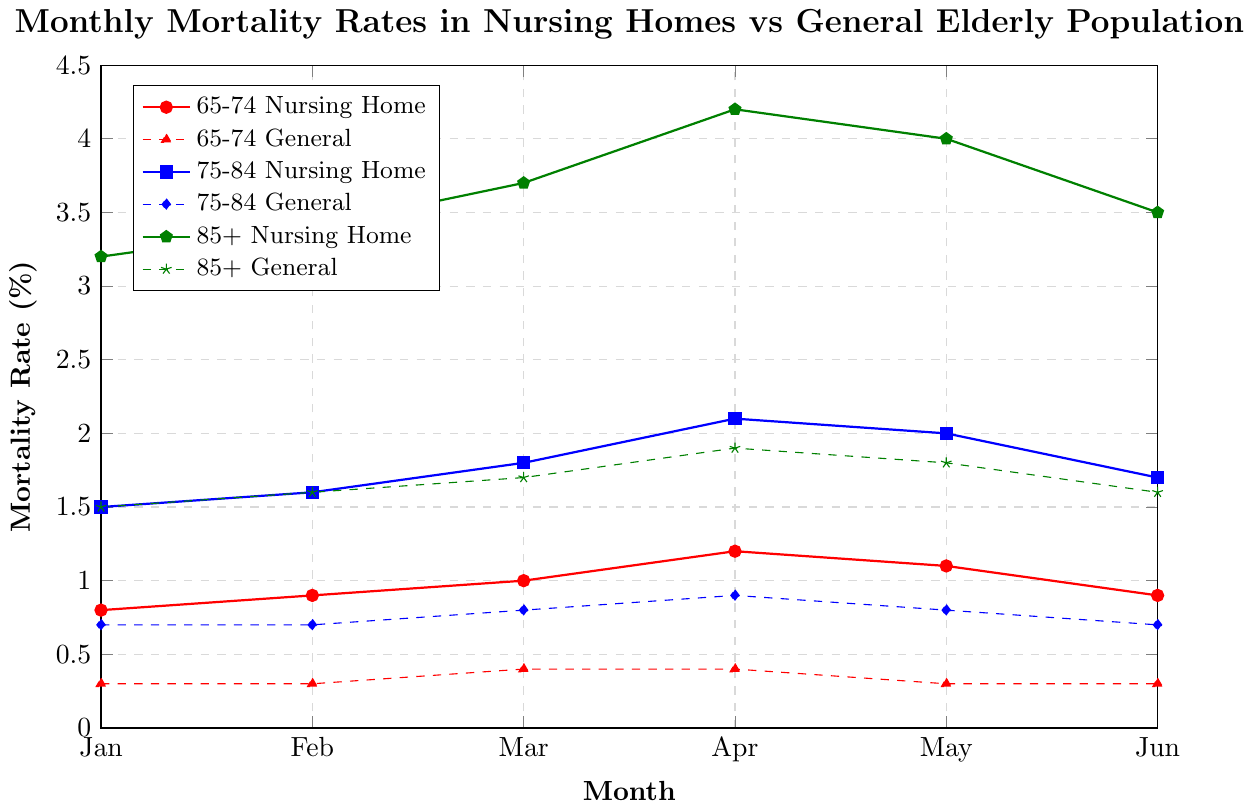what is the mortality rate for the 75-84 age group in nursing homes in April? The figure shows the monthly mortality rates for different age groups. Locate the 75-84 age group nursing home line (blue line with square markers) and find the value corresponding to April (xtick label "Apr").
Answer: 2.1 how does the general elderly mortality rate for the 85+ age group in February compare to that in June? Locate the green dashed line with star markers (representing the general elderly 85+ age group) and compare the values at the xtick labels "Feb" and "Jun".
Answer: 1.6 is equal to 1.6 what is the difference between the nursing home mortality rate and the general elderly mortality rate for the 65-74 age group in January? Locate the red solid line with circle markers (65-74 nursing home) and the red dashed line with triangle markers (65-74 general) at the xtick label "Jan". Subtract the general elderly rate from the nursing home rate: 0.8 - 0.3
Answer: 0.5 compare the trend of mortality rates from January to June between the 85+ group in nursing homes and the general elderly 85+ group. Observe the green solid line with pentagon markers (85+ nursing home) and the green dashed line with star markers (85+ general) from January to June. The nursing home rate generally increases to April and then decreases, while the general elderly rate increases slightly and then remains relatively stable.
Answer: 85+ nursing home increases then decreases, 85+ general increases then stable what is the average mortality rate for the 75-84 age group in general elderly population from January to June? Locate the blue dashed line with diamond markers (75-84 general elderly) and sum the values from "Jan" to "Jun": 0.7 + 0.7 + 0.8 + 0.9 + 0.8 + 0.7 = 4.6, then divide by 6.
Answer: 0.77 what's the highest monthly mortality rate observed in the data? Identify the highest value among all the plotted lines. The green solid line with pentagon markers (85+ nursing home) reaches the highest value at "Apr" (4.2).
Answer: 4.2 which age group showed the most noticeable increase in the nursing home mortality rate from January to April? Observe the slopes of the solid lines from January to April for each age group. The green solid line (85+ nursing home) shows the steepest increase from 3.2 to 4.2.
Answer: 85+ what is the difference between the highest and lowest mortality rates recorded in the general elderly population for all age groups combined? Identify the highest and lowest values across all dashed lines. Highest: 85+ general in April (1.9), Lowest: 65-74 general in Jan, Feb, May, Jun (0.3). Subtract the lowest from the highest: 1.9 - 0.3.
Answer: 1.6 